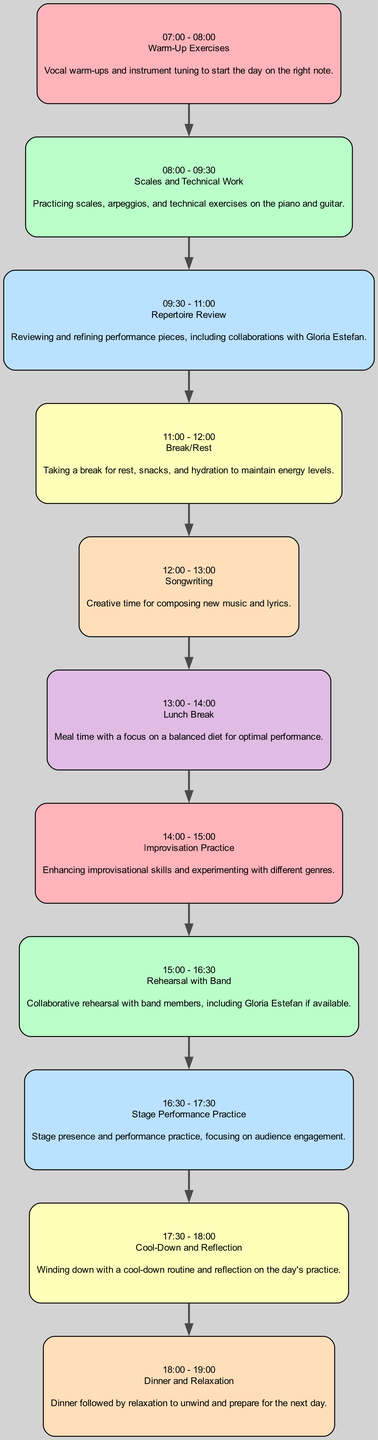What activity is scheduled from 07:00 to 08:00? By examining the first node in the diagram, it states that the activity scheduled for this time is "Warm-Up Exercises."
Answer: Warm-Up Exercises How many activities are included in the daily practice routine? Counting all the individual nodes displayed in the diagram, there are a total of 11 activities outlined.
Answer: 11 What follows "Repertoire Review" in the practice routine? Looking at the connection in the diagram, the node directly following "Repertoire Review" is labeled "Break/Rest."
Answer: Break/Rest What activity is set before the lunch break? By checking the node preceding the "Lunch Break," it shows "Songwriting" as the last activity before lunch.
Answer: Songwriting How long is the "Stage Performance Practice"? Observing the time allocation for the "Stage Performance Practice" node, it indicates that this activity lasts for one hour.
Answer: 1 hour Which activity includes collaboration with Gloria Estefan? Analyzing the nodes, both "Repertoire Review" and "Rehearsal with Band" mention collaboration with Gloria Estefan, but "Rehearsal with Band" specifies it more clearly.
Answer: Rehearsal with Band What is the focus during the "Improvisation Practice" time? The description for "Improvisation Practice" indicates that the focus is on enhancing improvisational skills and experimenting with different genres.
Answer: Enhancing improvisational skills How many activities include a break for rest? In the diagram, there are two nodes related to rest: "Break/Rest" and "Dinner and Relaxation," which both mention taking breaks for nourishment and relaxation.
Answer: 2 What is the final activity of the daily practice routine? The last node in the diagram is labeled "Dinner and Relaxation," indicating it is the concluding activity of the day.
Answer: Dinner and Relaxation 